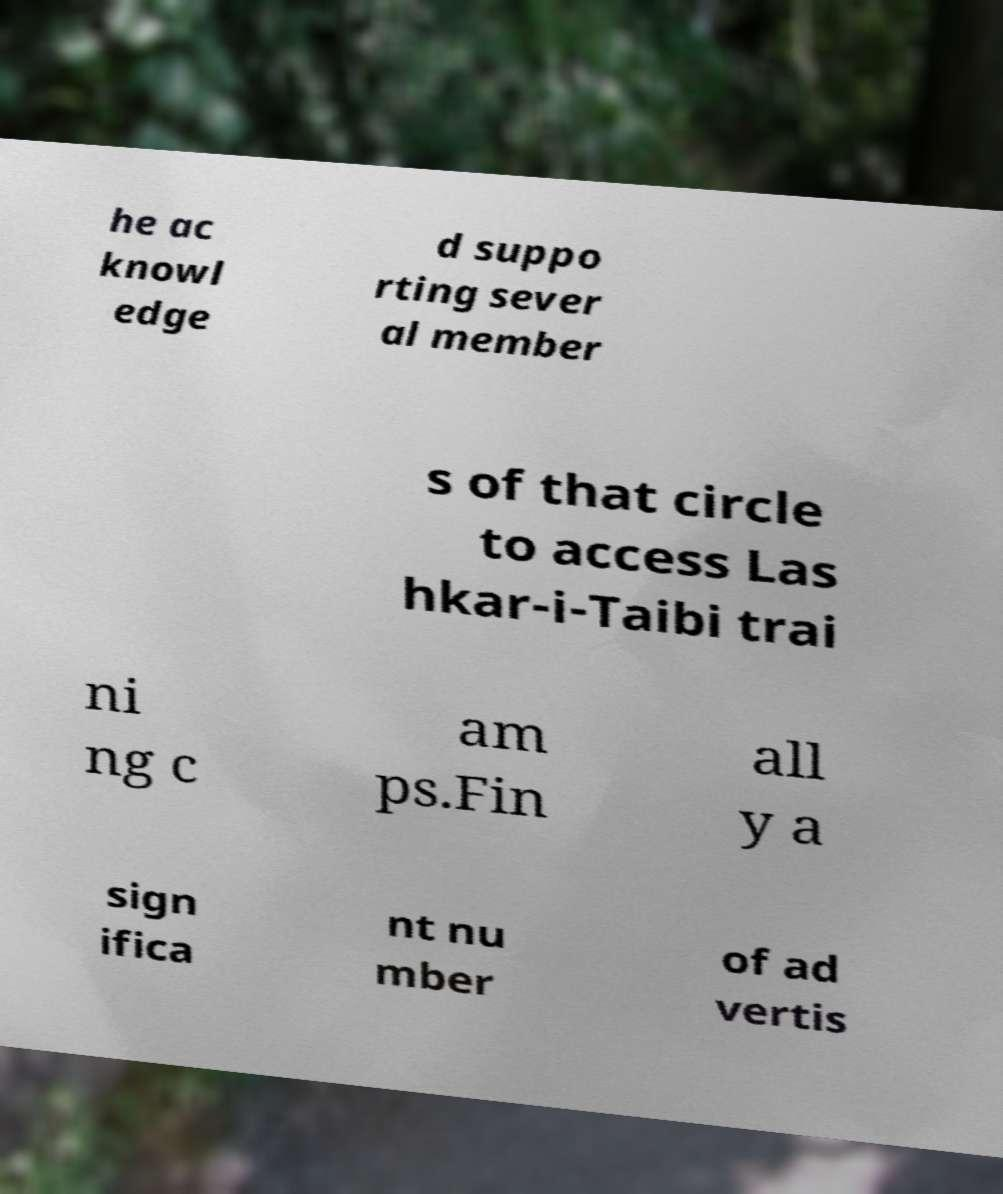Please read and relay the text visible in this image. What does it say? he ac knowl edge d suppo rting sever al member s of that circle to access Las hkar-i-Taibi trai ni ng c am ps.Fin all y a sign ifica nt nu mber of ad vertis 